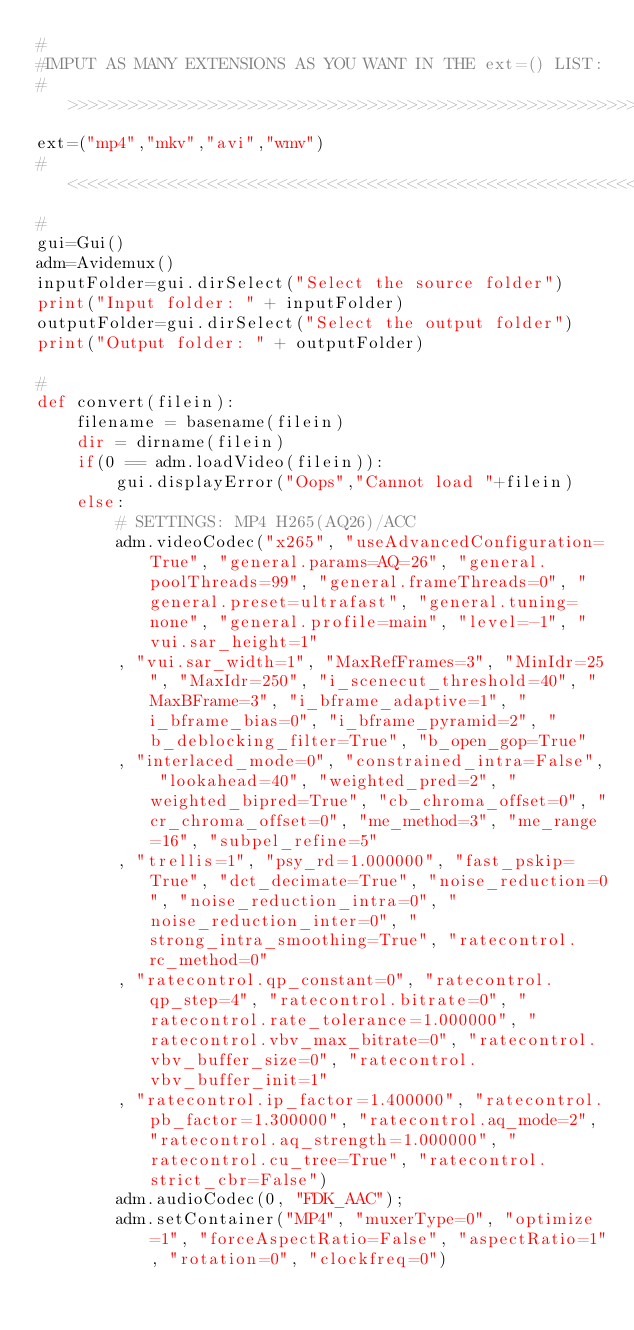<code> <loc_0><loc_0><loc_500><loc_500><_Python_>#
#IMPUT AS MANY EXTENSIONS AS YOU WANT IN THE ext=() LIST:
#>>>>>>>>>>>>>>>>>>>>>>>>>>>>>>>>>>>>>>>>>>>>>>>>>>>>>>>>>>>>>>>>>>>>>>>>>>>>>>>>>>>>>>>>>>
ext=("mp4","mkv","avi","wmv")
#<<<<<<<<<<<<<<<<<<<<<<<<<<<<<<<<<<<<<<<<<<<<<<<<<<<<<<<<<<<<<<<<<<<<<<<<<<<<<<<<<<<<<<<<<<
#
gui=Gui()
adm=Avidemux()
inputFolder=gui.dirSelect("Select the source folder")
print("Input folder: " + inputFolder)
outputFolder=gui.dirSelect("Select the output folder")
print("Output folder: " + outputFolder)

#
def convert(filein):
    filename = basename(filein)
    dir = dirname(filein)
    if(0 == adm.loadVideo(filein)):
        gui.displayError("Oops","Cannot load "+filein)
    else:
        # SETTINGS: MP4 H265(AQ26)/ACC
        adm.videoCodec("x265", "useAdvancedConfiguration=True", "general.params=AQ=26", "general.poolThreads=99", "general.frameThreads=0", "general.preset=ultrafast", "general.tuning=none", "general.profile=main", "level=-1", "vui.sar_height=1"
        , "vui.sar_width=1", "MaxRefFrames=3", "MinIdr=25", "MaxIdr=250", "i_scenecut_threshold=40", "MaxBFrame=3", "i_bframe_adaptive=1", "i_bframe_bias=0", "i_bframe_pyramid=2", "b_deblocking_filter=True", "b_open_gop=True"
        , "interlaced_mode=0", "constrained_intra=False", "lookahead=40", "weighted_pred=2", "weighted_bipred=True", "cb_chroma_offset=0", "cr_chroma_offset=0", "me_method=3", "me_range=16", "subpel_refine=5"
        , "trellis=1", "psy_rd=1.000000", "fast_pskip=True", "dct_decimate=True", "noise_reduction=0", "noise_reduction_intra=0", "noise_reduction_inter=0", "strong_intra_smoothing=True", "ratecontrol.rc_method=0"
        , "ratecontrol.qp_constant=0", "ratecontrol.qp_step=4", "ratecontrol.bitrate=0", "ratecontrol.rate_tolerance=1.000000", "ratecontrol.vbv_max_bitrate=0", "ratecontrol.vbv_buffer_size=0", "ratecontrol.vbv_buffer_init=1"
        , "ratecontrol.ip_factor=1.400000", "ratecontrol.pb_factor=1.300000", "ratecontrol.aq_mode=2", "ratecontrol.aq_strength=1.000000", "ratecontrol.cu_tree=True", "ratecontrol.strict_cbr=False")
        adm.audioCodec(0, "FDK_AAC");
        adm.setContainer("MP4", "muxerType=0", "optimize=1", "forceAspectRatio=False", "aspectRatio=1", "rotation=0", "clockfreq=0")</code> 